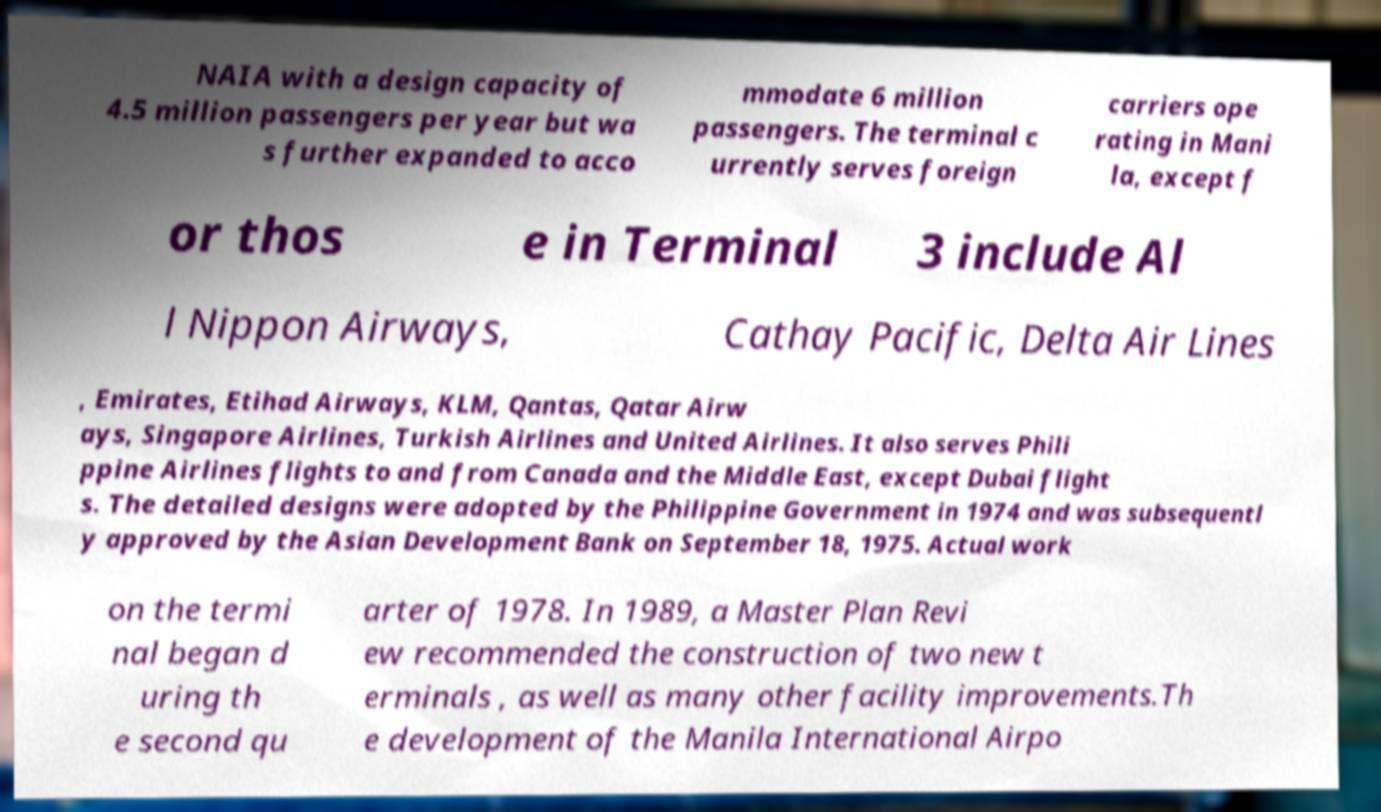Can you read and provide the text displayed in the image?This photo seems to have some interesting text. Can you extract and type it out for me? NAIA with a design capacity of 4.5 million passengers per year but wa s further expanded to acco mmodate 6 million passengers. The terminal c urrently serves foreign carriers ope rating in Mani la, except f or thos e in Terminal 3 include Al l Nippon Airways, Cathay Pacific, Delta Air Lines , Emirates, Etihad Airways, KLM, Qantas, Qatar Airw ays, Singapore Airlines, Turkish Airlines and United Airlines. It also serves Phili ppine Airlines flights to and from Canada and the Middle East, except Dubai flight s. The detailed designs were adopted by the Philippine Government in 1974 and was subsequentl y approved by the Asian Development Bank on September 18, 1975. Actual work on the termi nal began d uring th e second qu arter of 1978. In 1989, a Master Plan Revi ew recommended the construction of two new t erminals , as well as many other facility improvements.Th e development of the Manila International Airpo 